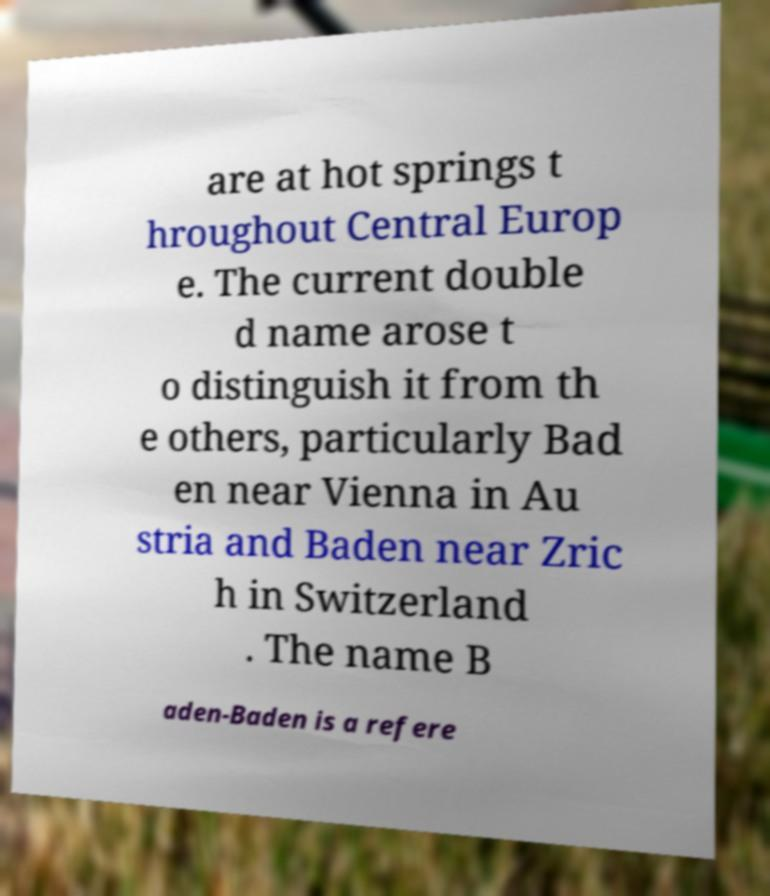Please identify and transcribe the text found in this image. are at hot springs t hroughout Central Europ e. The current double d name arose t o distinguish it from th e others, particularly Bad en near Vienna in Au stria and Baden near Zric h in Switzerland . The name B aden-Baden is a refere 